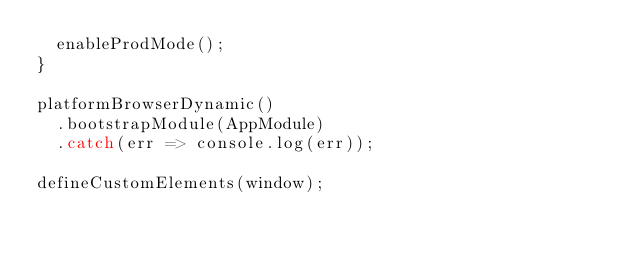<code> <loc_0><loc_0><loc_500><loc_500><_TypeScript_>  enableProdMode();
}

platformBrowserDynamic()
  .bootstrapModule(AppModule)
  .catch(err => console.log(err));

defineCustomElements(window);
</code> 